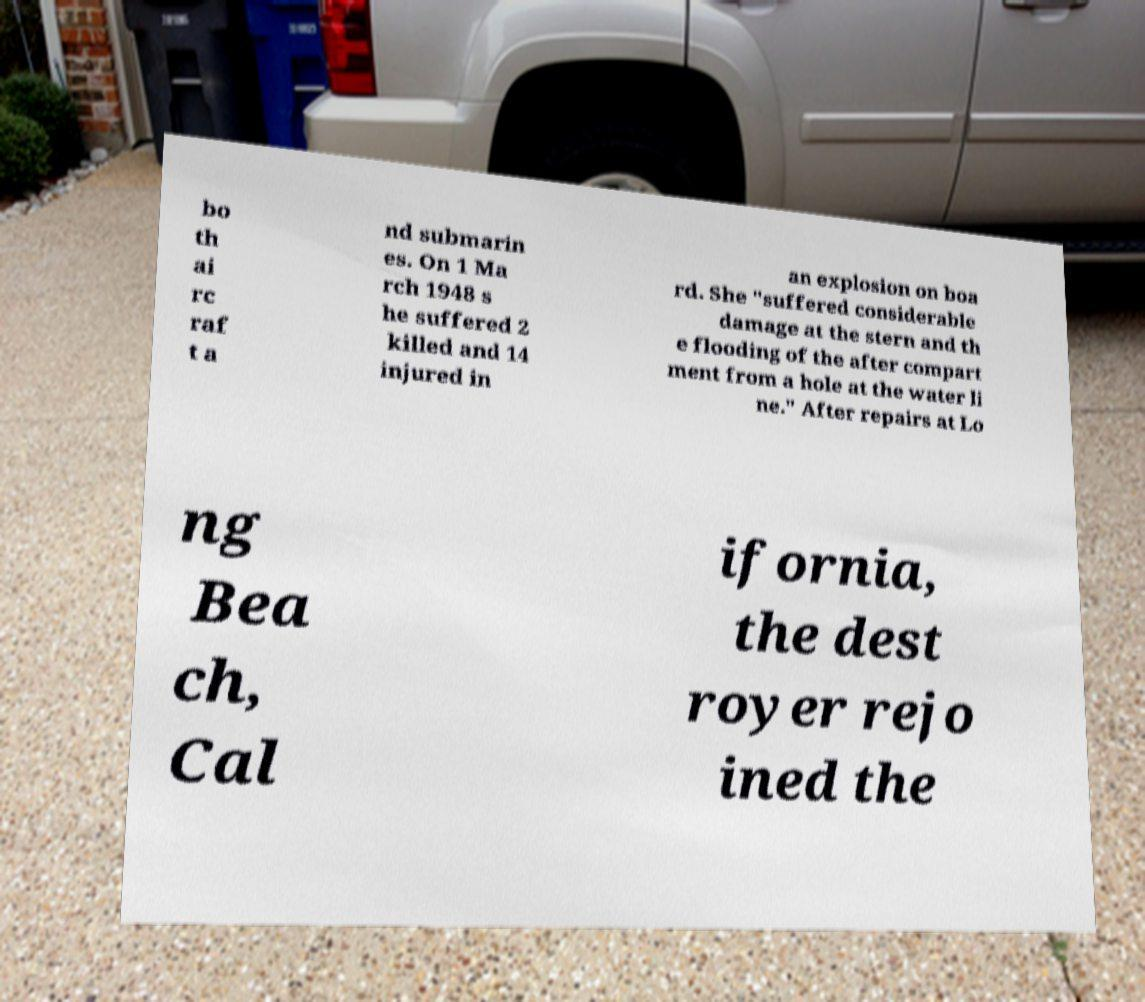Please identify and transcribe the text found in this image. bo th ai rc raf t a nd submarin es. On 1 Ma rch 1948 s he suffered 2 killed and 14 injured in an explosion on boa rd. She "suffered considerable damage at the stern and th e flooding of the after compart ment from a hole at the water li ne." After repairs at Lo ng Bea ch, Cal ifornia, the dest royer rejo ined the 